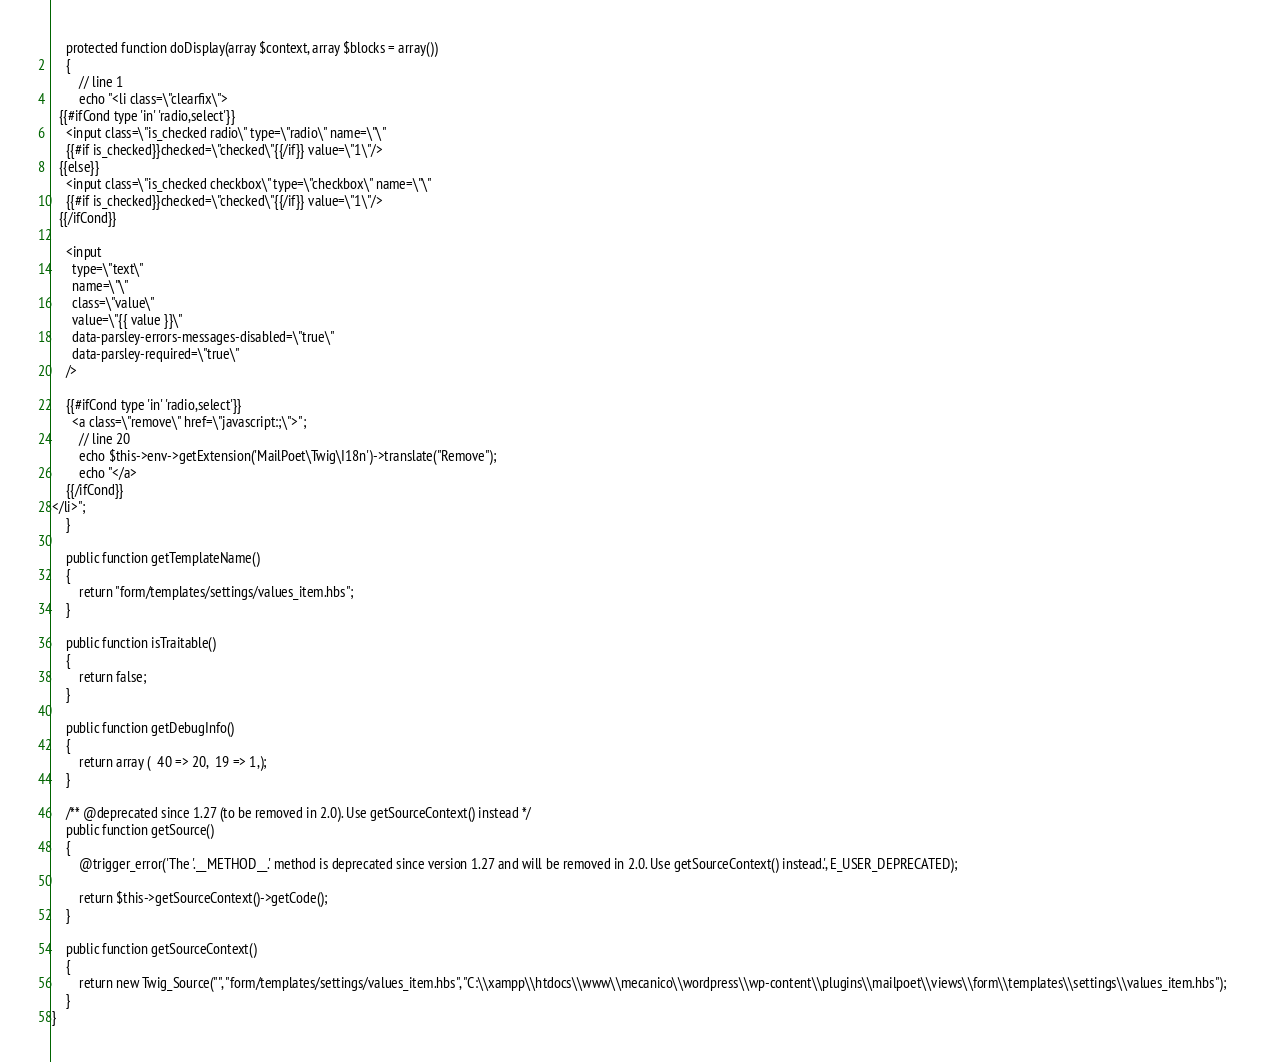Convert code to text. <code><loc_0><loc_0><loc_500><loc_500><_PHP_>    protected function doDisplay(array $context, array $blocks = array())
    {
        // line 1
        echo "<li class=\"clearfix\">
  {{#ifCond type 'in' 'radio,select'}}
    <input class=\"is_checked radio\" type=\"radio\" name=\"\"
    {{#if is_checked}}checked=\"checked\"{{/if}} value=\"1\"/>
  {{else}}
    <input class=\"is_checked checkbox\" type=\"checkbox\" name=\"\"
    {{#if is_checked}}checked=\"checked\"{{/if}} value=\"1\"/>
  {{/ifCond}}

    <input
      type=\"text\"
      name=\"\"
      class=\"value\"
      value=\"{{ value }}\"
      data-parsley-errors-messages-disabled=\"true\"
      data-parsley-required=\"true\"
    />

    {{#ifCond type 'in' 'radio,select'}}
      <a class=\"remove\" href=\"javascript:;\">";
        // line 20
        echo $this->env->getExtension('MailPoet\Twig\I18n')->translate("Remove");
        echo "</a>
    {{/ifCond}}
</li>";
    }

    public function getTemplateName()
    {
        return "form/templates/settings/values_item.hbs";
    }

    public function isTraitable()
    {
        return false;
    }

    public function getDebugInfo()
    {
        return array (  40 => 20,  19 => 1,);
    }

    /** @deprecated since 1.27 (to be removed in 2.0). Use getSourceContext() instead */
    public function getSource()
    {
        @trigger_error('The '.__METHOD__.' method is deprecated since version 1.27 and will be removed in 2.0. Use getSourceContext() instead.', E_USER_DEPRECATED);

        return $this->getSourceContext()->getCode();
    }

    public function getSourceContext()
    {
        return new Twig_Source("", "form/templates/settings/values_item.hbs", "C:\\xampp\\htdocs\\www\\mecanico\\wordpress\\wp-content\\plugins\\mailpoet\\views\\form\\templates\\settings\\values_item.hbs");
    }
}
</code> 